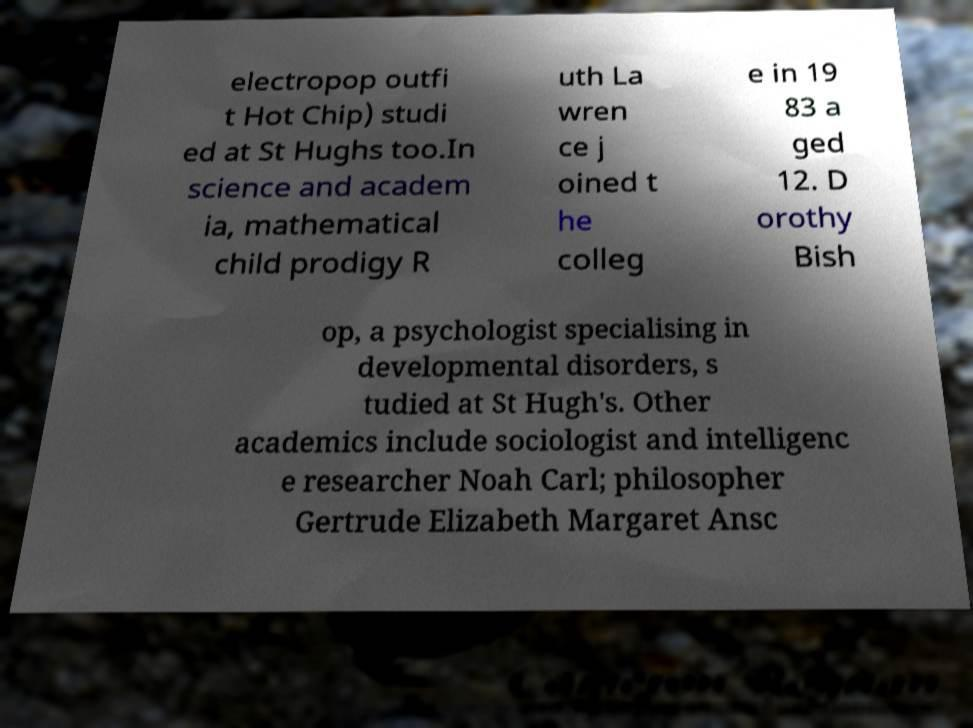What messages or text are displayed in this image? I need them in a readable, typed format. electropop outfi t Hot Chip) studi ed at St Hughs too.In science and academ ia, mathematical child prodigy R uth La wren ce j oined t he colleg e in 19 83 a ged 12. D orothy Bish op, a psychologist specialising in developmental disorders, s tudied at St Hugh's. Other academics include sociologist and intelligenc e researcher Noah Carl; philosopher Gertrude Elizabeth Margaret Ansc 